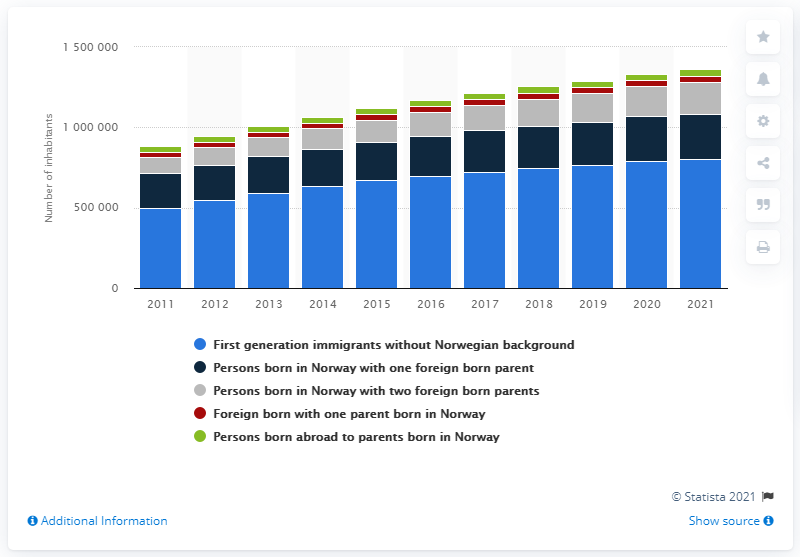Point out several critical features in this image. In 2021, 197,848 Norwegians were born to foreign-born parents. There were approximately 800,940 first-generation immigrants living in Norway in 2021. 